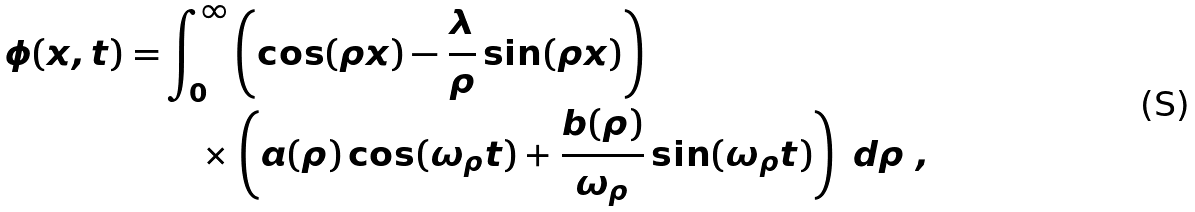<formula> <loc_0><loc_0><loc_500><loc_500>\phi ( x , t ) = & \int _ { 0 } ^ { \infty } \left ( \cos ( \rho x ) - \frac { \lambda } { \rho } \sin ( \rho x ) \right ) \\ & \quad \times \left ( a ( \rho ) \cos ( \omega _ { \rho } t ) + \frac { b ( \rho ) } { \omega _ { \rho } } \sin ( \omega _ { \rho } t ) \right ) \ d \rho \ ,</formula> 